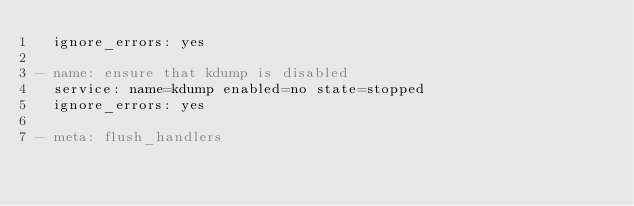Convert code to text. <code><loc_0><loc_0><loc_500><loc_500><_YAML_>  ignore_errors: yes

- name: ensure that kdump is disabled
  service: name=kdump enabled=no state=stopped
  ignore_errors: yes

- meta: flush_handlers
</code> 